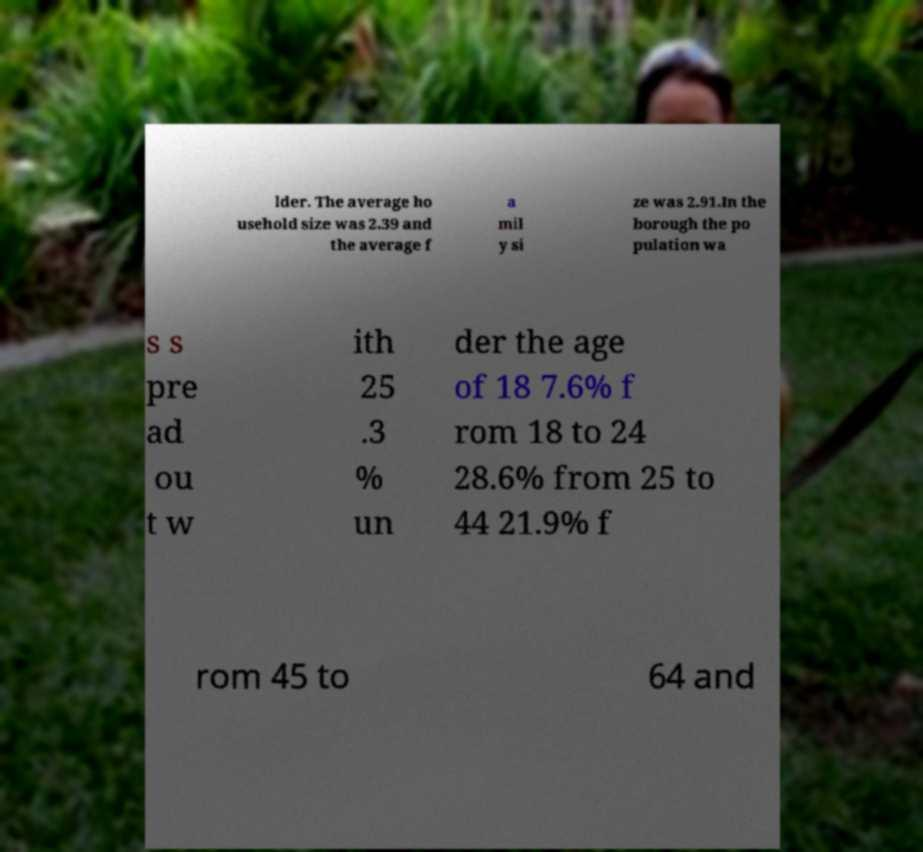Can you accurately transcribe the text from the provided image for me? lder. The average ho usehold size was 2.39 and the average f a mil y si ze was 2.91.In the borough the po pulation wa s s pre ad ou t w ith 25 .3 % un der the age of 18 7.6% f rom 18 to 24 28.6% from 25 to 44 21.9% f rom 45 to 64 and 